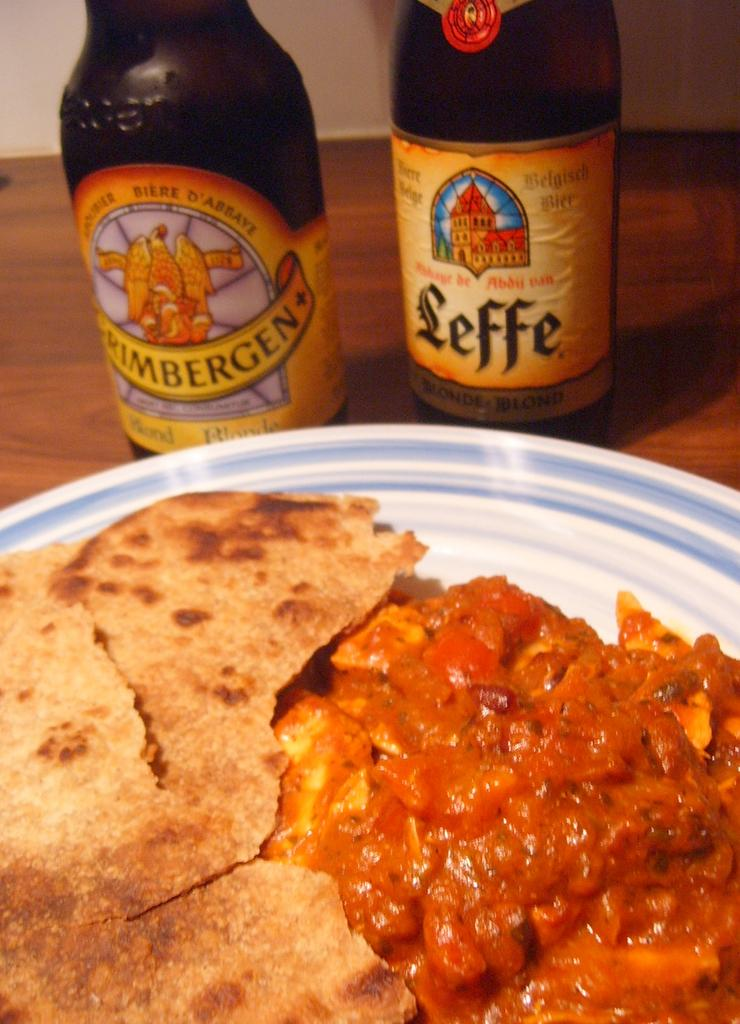<image>
Describe the image concisely. A bottle of Leffe beer sits next to another bottle and a plate of food. 